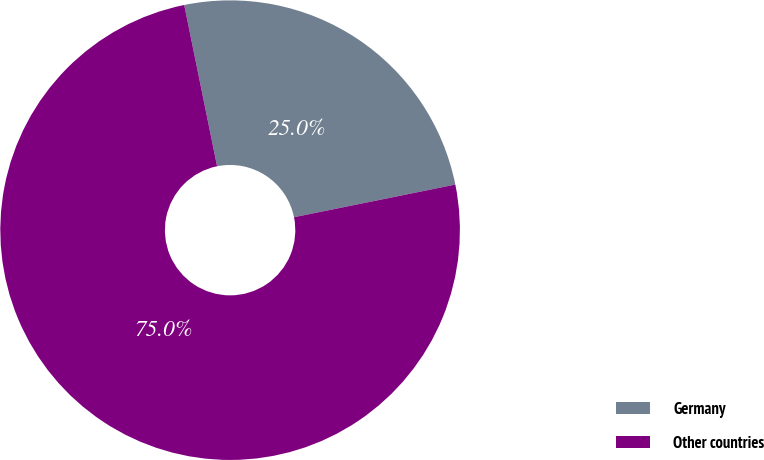Convert chart. <chart><loc_0><loc_0><loc_500><loc_500><pie_chart><fcel>Germany<fcel>Other countries<nl><fcel>25.02%<fcel>74.98%<nl></chart> 